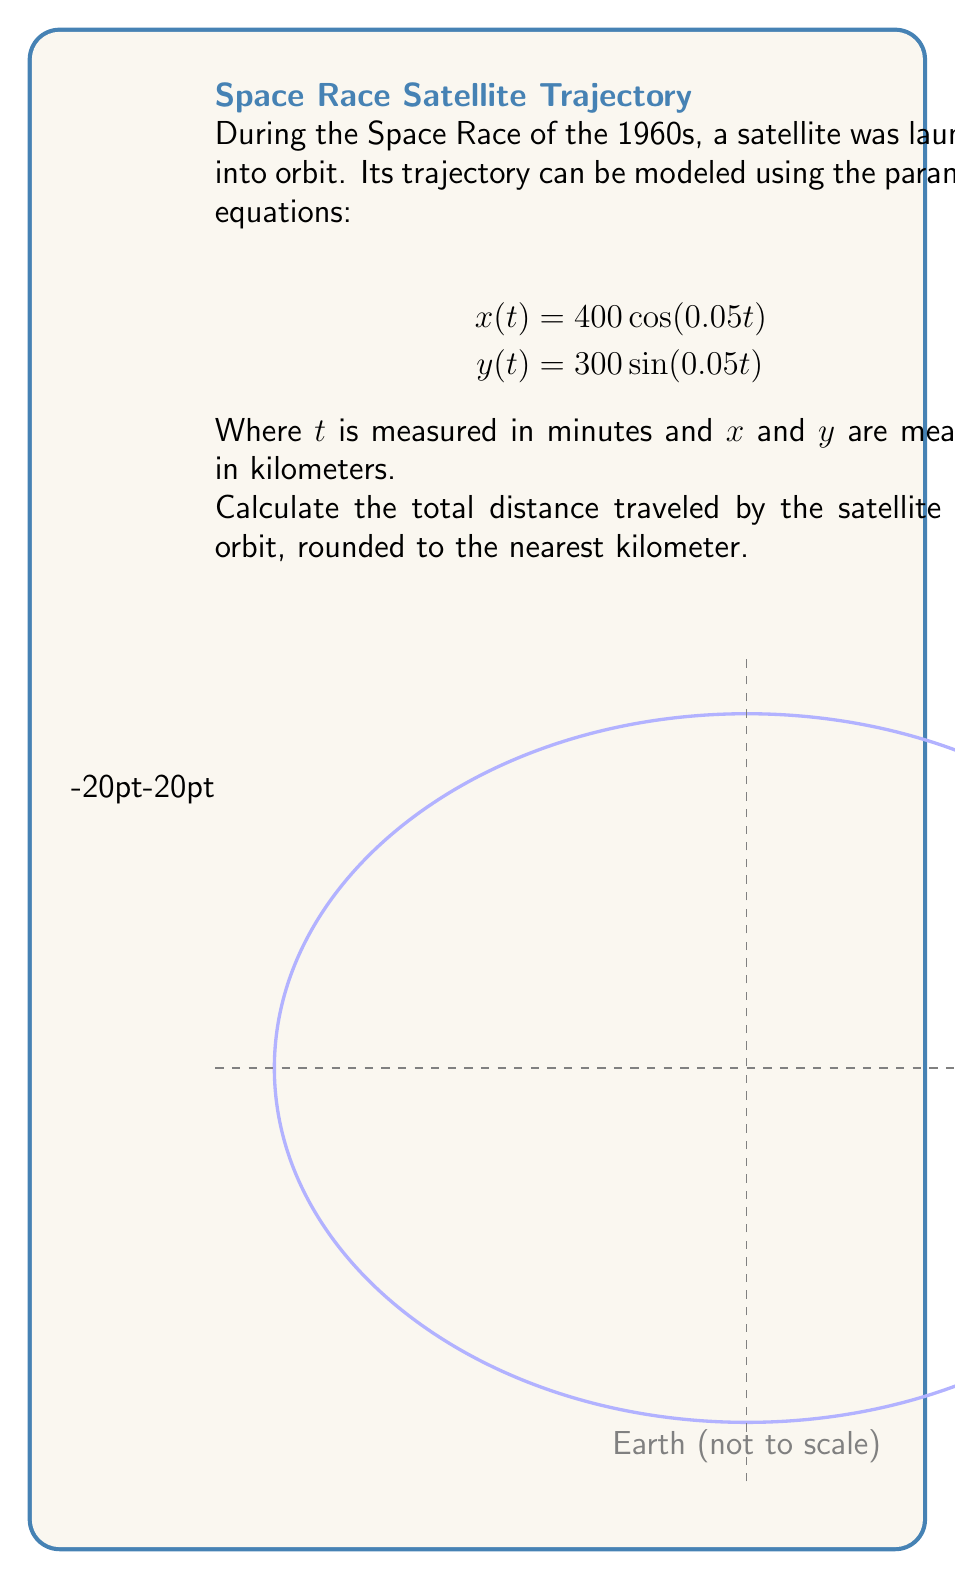Provide a solution to this math problem. To solve this problem, we'll follow these steps:

1) The trajectory forms an ellipse. The distance traveled is the circumference of this ellipse.

2) For an ellipse with semi-major axis $a$ and semi-minor axis $b$, we can approximate the circumference using Ramanujan's formula:

   $$C \approx \pi(a+b)\left(1 + \frac{3h}{10 + \sqrt{4-3h}}\right)$$
   
   where $h = \frac{(a-b)^2}{(a+b)^2}$

3) From the given equations, we can see that $a = 400$ km and $b = 300$ km.

4) Let's calculate $h$:
   $$h = \frac{(400-300)^2}{(400+300)^2} = \frac{10000}{490000} = \frac{1}{49}$$

5) Now we can substitute these values into Ramanujan's formula:

   $$C \approx \pi(400+300)\left(1 + \frac{3(\frac{1}{49})}{10 + \sqrt{4-3(\frac{1}{49})}}\right)$$

6) Simplifying:
   $$C \approx 2199.11$$ km

7) Rounding to the nearest kilometer:
   $$C \approx 2199$$ km
Answer: 2199 km 